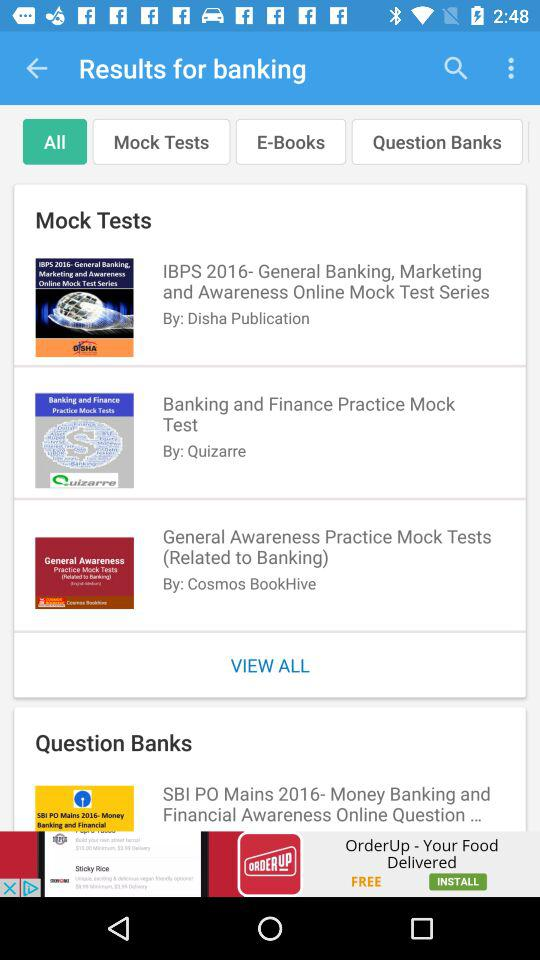How many question banks are there for banking?
Answer the question using a single word or phrase. 1 